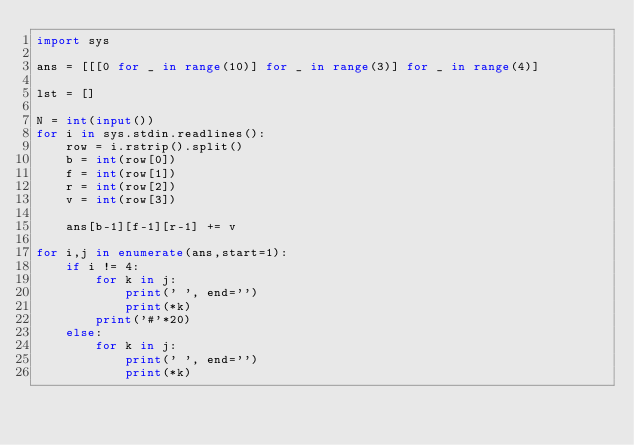<code> <loc_0><loc_0><loc_500><loc_500><_Python_>import sys

ans = [[[0 for _ in range(10)] for _ in range(3)] for _ in range(4)]

lst = []

N = int(input())
for i in sys.stdin.readlines():
    row = i.rstrip().split()
    b = int(row[0])
    f = int(row[1])
    r = int(row[2])
    v = int(row[3])
    
    ans[b-1][f-1][r-1] += v
    
for i,j in enumerate(ans,start=1):
    if i != 4:
        for k in j:
            print(' ', end='')
            print(*k)
        print('#'*20)
    else:
        for k in j:
            print(' ', end='')
            print(*k)

        
</code> 